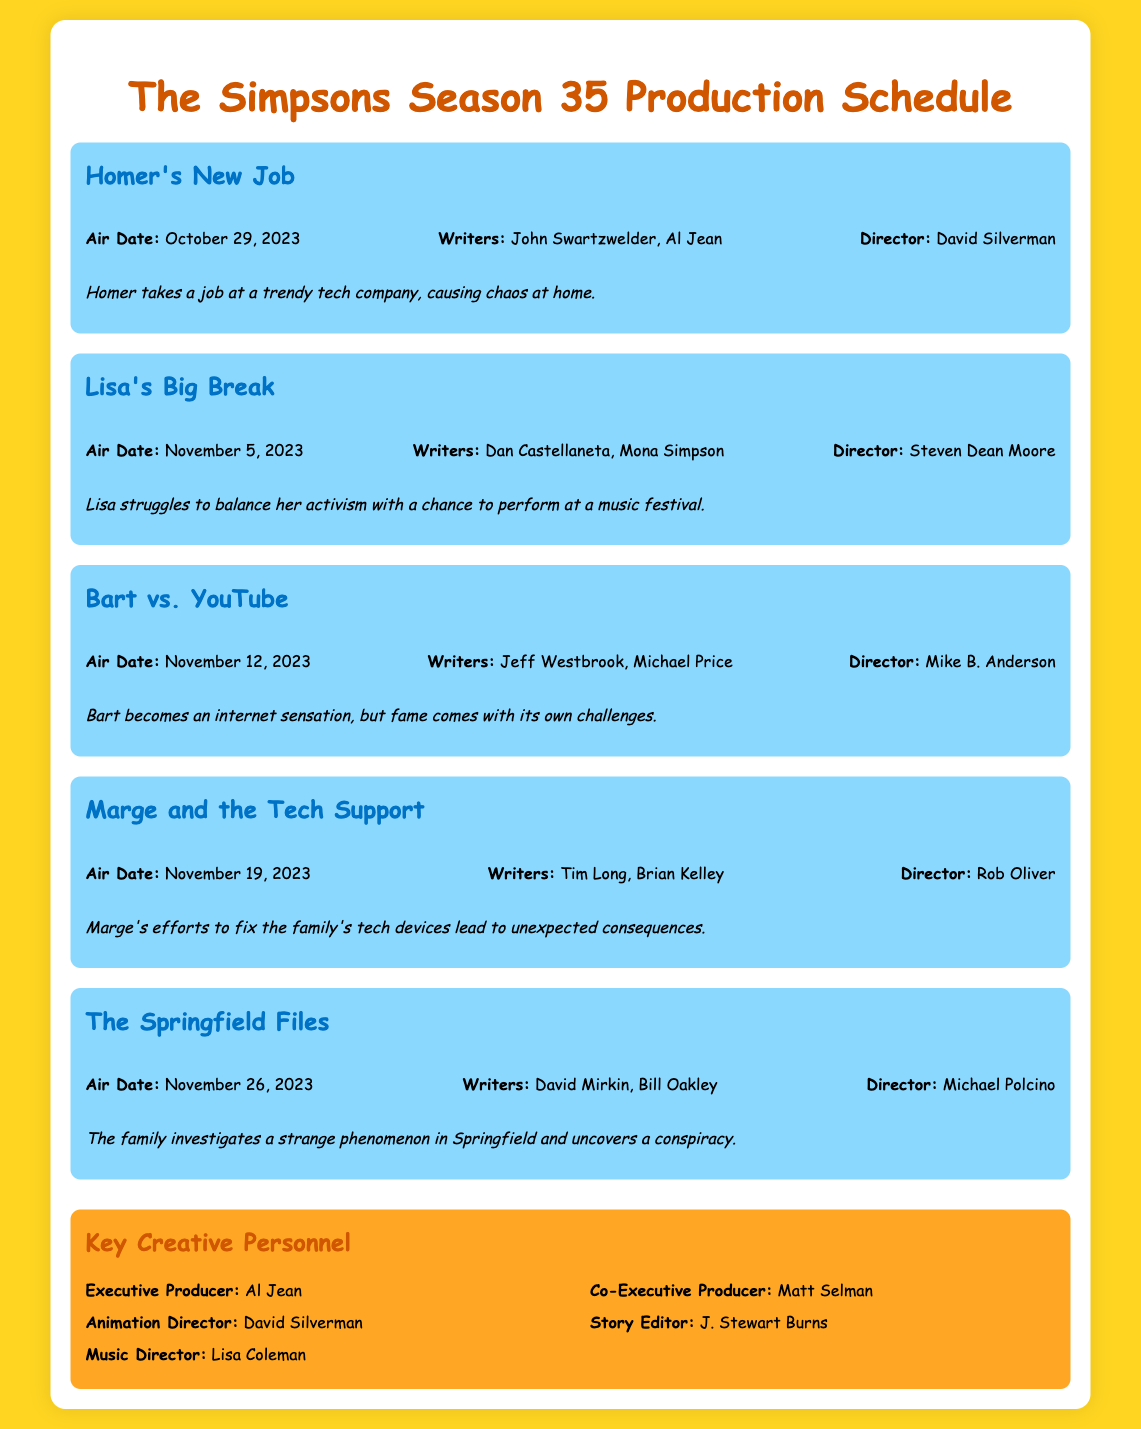What is the title of the premiere episode? The title of the premiere episode is found in the document under the first episode listed.
Answer: Homer's New Job What is the air date for "Lisa's Big Break"? The air date for "Lisa's Big Break" is specified in the episode info section.
Answer: November 5, 2023 Who directed "Bart vs. YouTube"? The director's name for "Bart vs. YouTube" is listed in the episode details.
Answer: Mike B. Anderson Who are the writers of "Marge and the Tech Support"? The writers can be found in the episode information and include all contributing authors.
Answer: Tim Long, Brian Kelley Which episode is about a strange phenomenon in Springfield? The episode title related to investigating a strange phenomenon in Springfield is provided in the document.
Answer: The Springfield Files How many episodes are listed in the document? The total number of episodes can be counted based on the number of episode sections in the document.
Answer: Five Who is the Executive Producer of this season? The Executive Producer's name is presented in the key creative personnel section of the document.
Answer: Al Jean What thematic issue does "Lisa's Big Break" tackle? The thematic issue related to "Lisa's Big Break" is mentioned in the episode description.
Answer: Activism and music Who is the Music Director? The Music Director’s name is mentioned in the key creative personnel section and identifies their role.
Answer: Lisa Coleman 